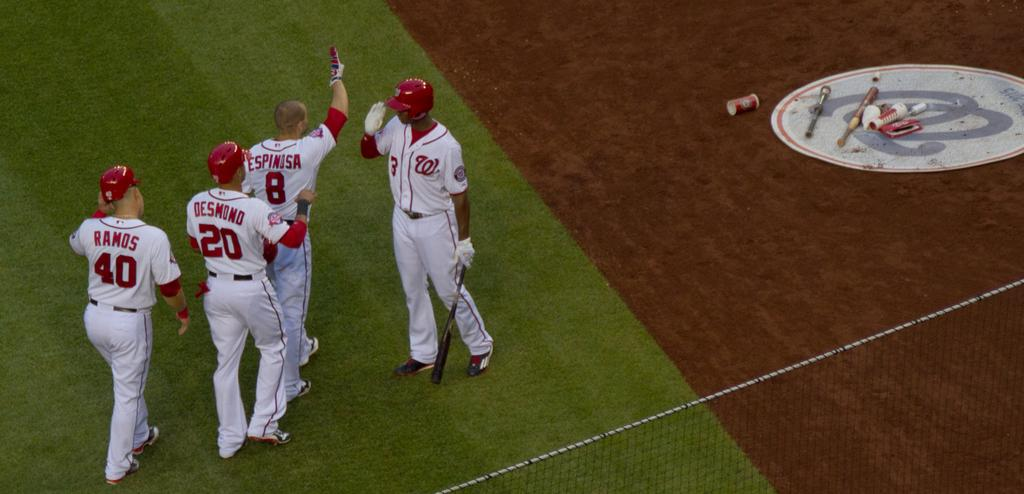<image>
Create a compact narrative representing the image presented. a player named Ramos among others with the number 40 